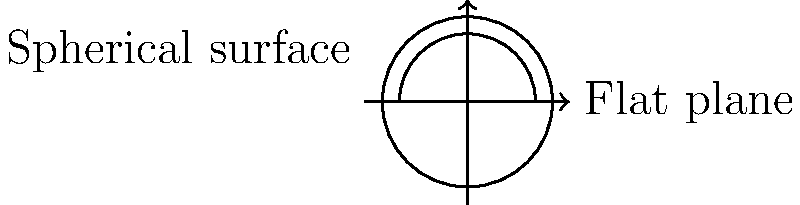In the context of Non-Euclidean Geometry, consider a circle with radius $r$ on a spherical surface and a circle with the same radius on a flat plane. How does the area of the circle on the spherical surface compare to the area of the circle on the flat plane? Assume the radius of the sphere is significantly larger than the radius of the circle. To understand the difference in areas, let's follow these steps:

1. Area of a circle on a flat plane:
   The formula is $A_{flat} = \pi r^2$

2. Area of a circle on a spherical surface:
   The formula is $A_{sphere} = 2\pi R^2(1 - \cos(\frac{r}{R}))$
   Where $R$ is the radius of the sphere and $r$ is the radius of the circle

3. Taylor series expansion of $\cos(x)$:
   $\cos(x) \approx 1 - \frac{x^2}{2!} + \frac{x^4}{4!} - ...$

4. Substituting $x = \frac{r}{R}$ in the Taylor expansion:
   $\cos(\frac{r}{R}) \approx 1 - \frac{1}{2}(\frac{r}{R})^2 + \frac{1}{24}(\frac{r}{R})^4 - ...$

5. Applying this to the spherical area formula:
   $A_{sphere} \approx 2\pi R^2(\frac{1}{2}(\frac{r}{R})^2 - \frac{1}{24}(\frac{r}{R})^4 + ...)$
   $= \pi r^2(1 - \frac{1}{12}(\frac{r}{R})^2 + ...)$

6. Comparing $A_{sphere}$ to $A_{flat}$:
   $A_{sphere} \approx \pi r^2(1 - \frac{1}{12}(\frac{r}{R})^2 + ...)$
   $A_{flat} = \pi r^2$

7. The difference:
   $A_{sphere} - A_{flat} \approx -\frac{1}{12}\pi r^4/R^2 + ...$

Therefore, the area of the circle on the spherical surface is slightly smaller than the area of the circle on the flat plane. The difference is proportional to $r^4/R^2$, which is very small when $R$ is much larger than $r$.
Answer: Slightly smaller 